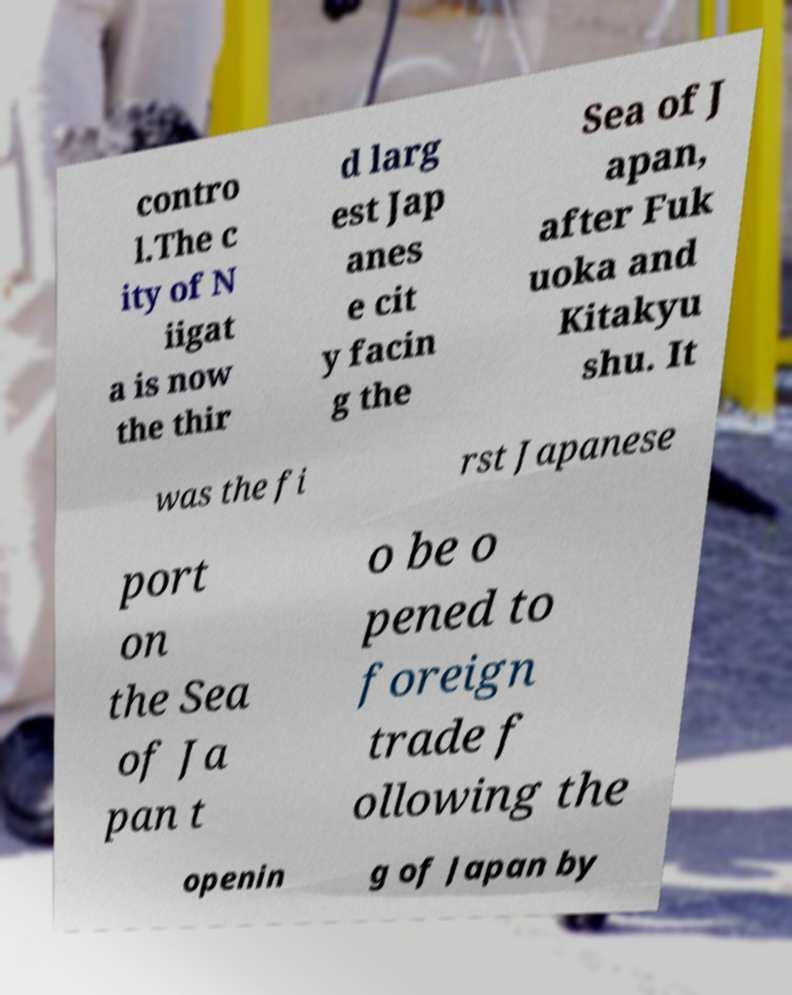Please read and relay the text visible in this image. What does it say? contro l.The c ity of N iigat a is now the thir d larg est Jap anes e cit y facin g the Sea of J apan, after Fuk uoka and Kitakyu shu. It was the fi rst Japanese port on the Sea of Ja pan t o be o pened to foreign trade f ollowing the openin g of Japan by 